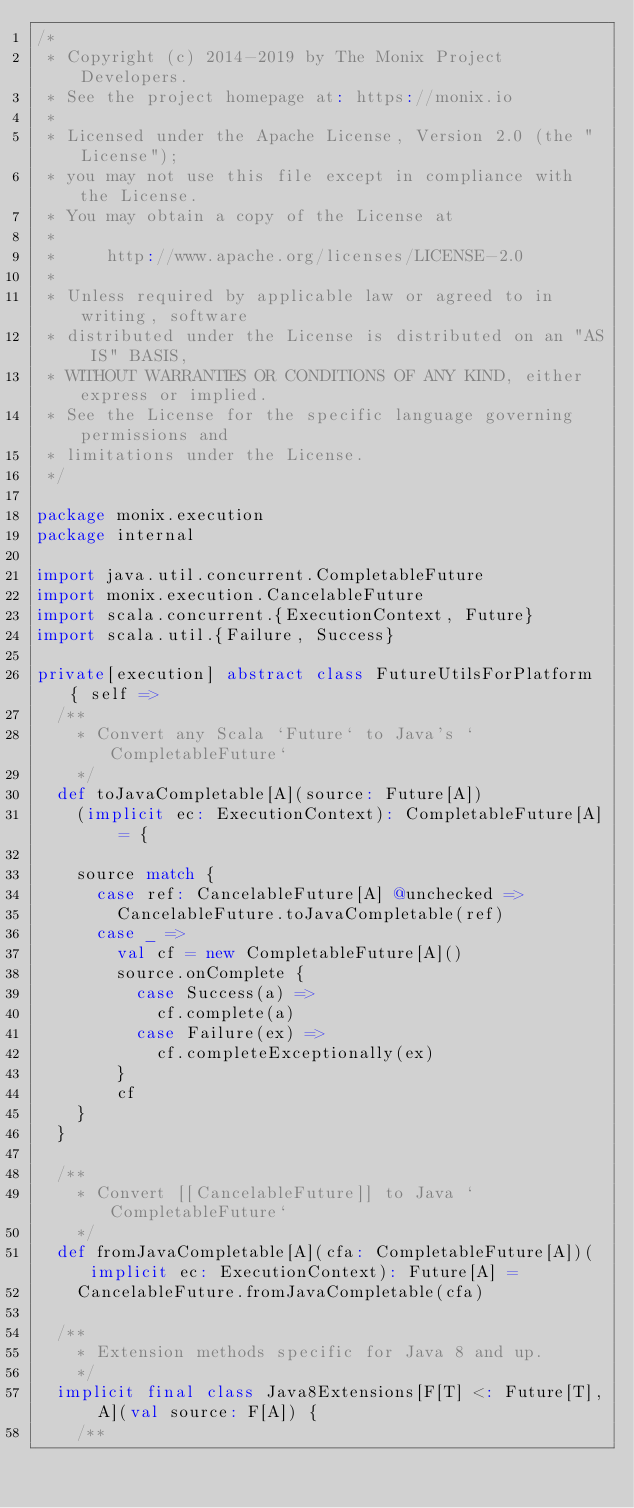<code> <loc_0><loc_0><loc_500><loc_500><_Scala_>/*
 * Copyright (c) 2014-2019 by The Monix Project Developers.
 * See the project homepage at: https://monix.io
 *
 * Licensed under the Apache License, Version 2.0 (the "License");
 * you may not use this file except in compliance with the License.
 * You may obtain a copy of the License at
 *
 *     http://www.apache.org/licenses/LICENSE-2.0
 *
 * Unless required by applicable law or agreed to in writing, software
 * distributed under the License is distributed on an "AS IS" BASIS,
 * WITHOUT WARRANTIES OR CONDITIONS OF ANY KIND, either express or implied.
 * See the License for the specific language governing permissions and
 * limitations under the License.
 */

package monix.execution
package internal

import java.util.concurrent.CompletableFuture
import monix.execution.CancelableFuture
import scala.concurrent.{ExecutionContext, Future}
import scala.util.{Failure, Success}

private[execution] abstract class FutureUtilsForPlatform { self =>
  /**
    * Convert any Scala `Future` to Java's `CompletableFuture`
    */
  def toJavaCompletable[A](source: Future[A])
    (implicit ec: ExecutionContext): CompletableFuture[A] = {

    source match {
      case ref: CancelableFuture[A] @unchecked =>
        CancelableFuture.toJavaCompletable(ref)
      case _ =>
        val cf = new CompletableFuture[A]()
        source.onComplete {
          case Success(a) =>
            cf.complete(a)
          case Failure(ex) =>
            cf.completeExceptionally(ex)
        }
        cf
    }
  }

  /**
    * Convert [[CancelableFuture]] to Java `CompletableFuture`
    */
  def fromJavaCompletable[A](cfa: CompletableFuture[A])(implicit ec: ExecutionContext): Future[A] =
    CancelableFuture.fromJavaCompletable(cfa)

  /**
    * Extension methods specific for Java 8 and up.
    */
  implicit final class Java8Extensions[F[T] <: Future[T], A](val source: F[A]) {
    /**</code> 